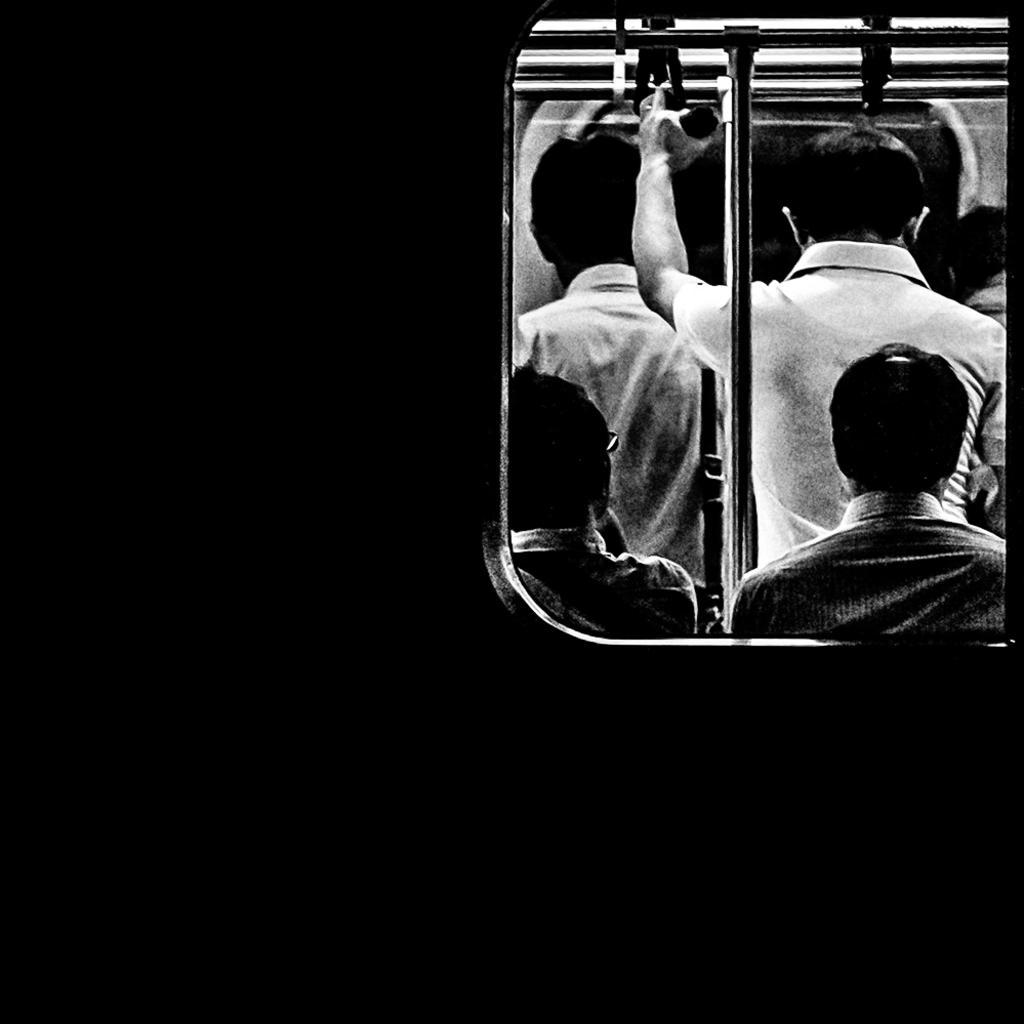Can you describe this image briefly? In this image there are persons standing and sitting. The man in the center is standing and holding a rope which is on the top. 